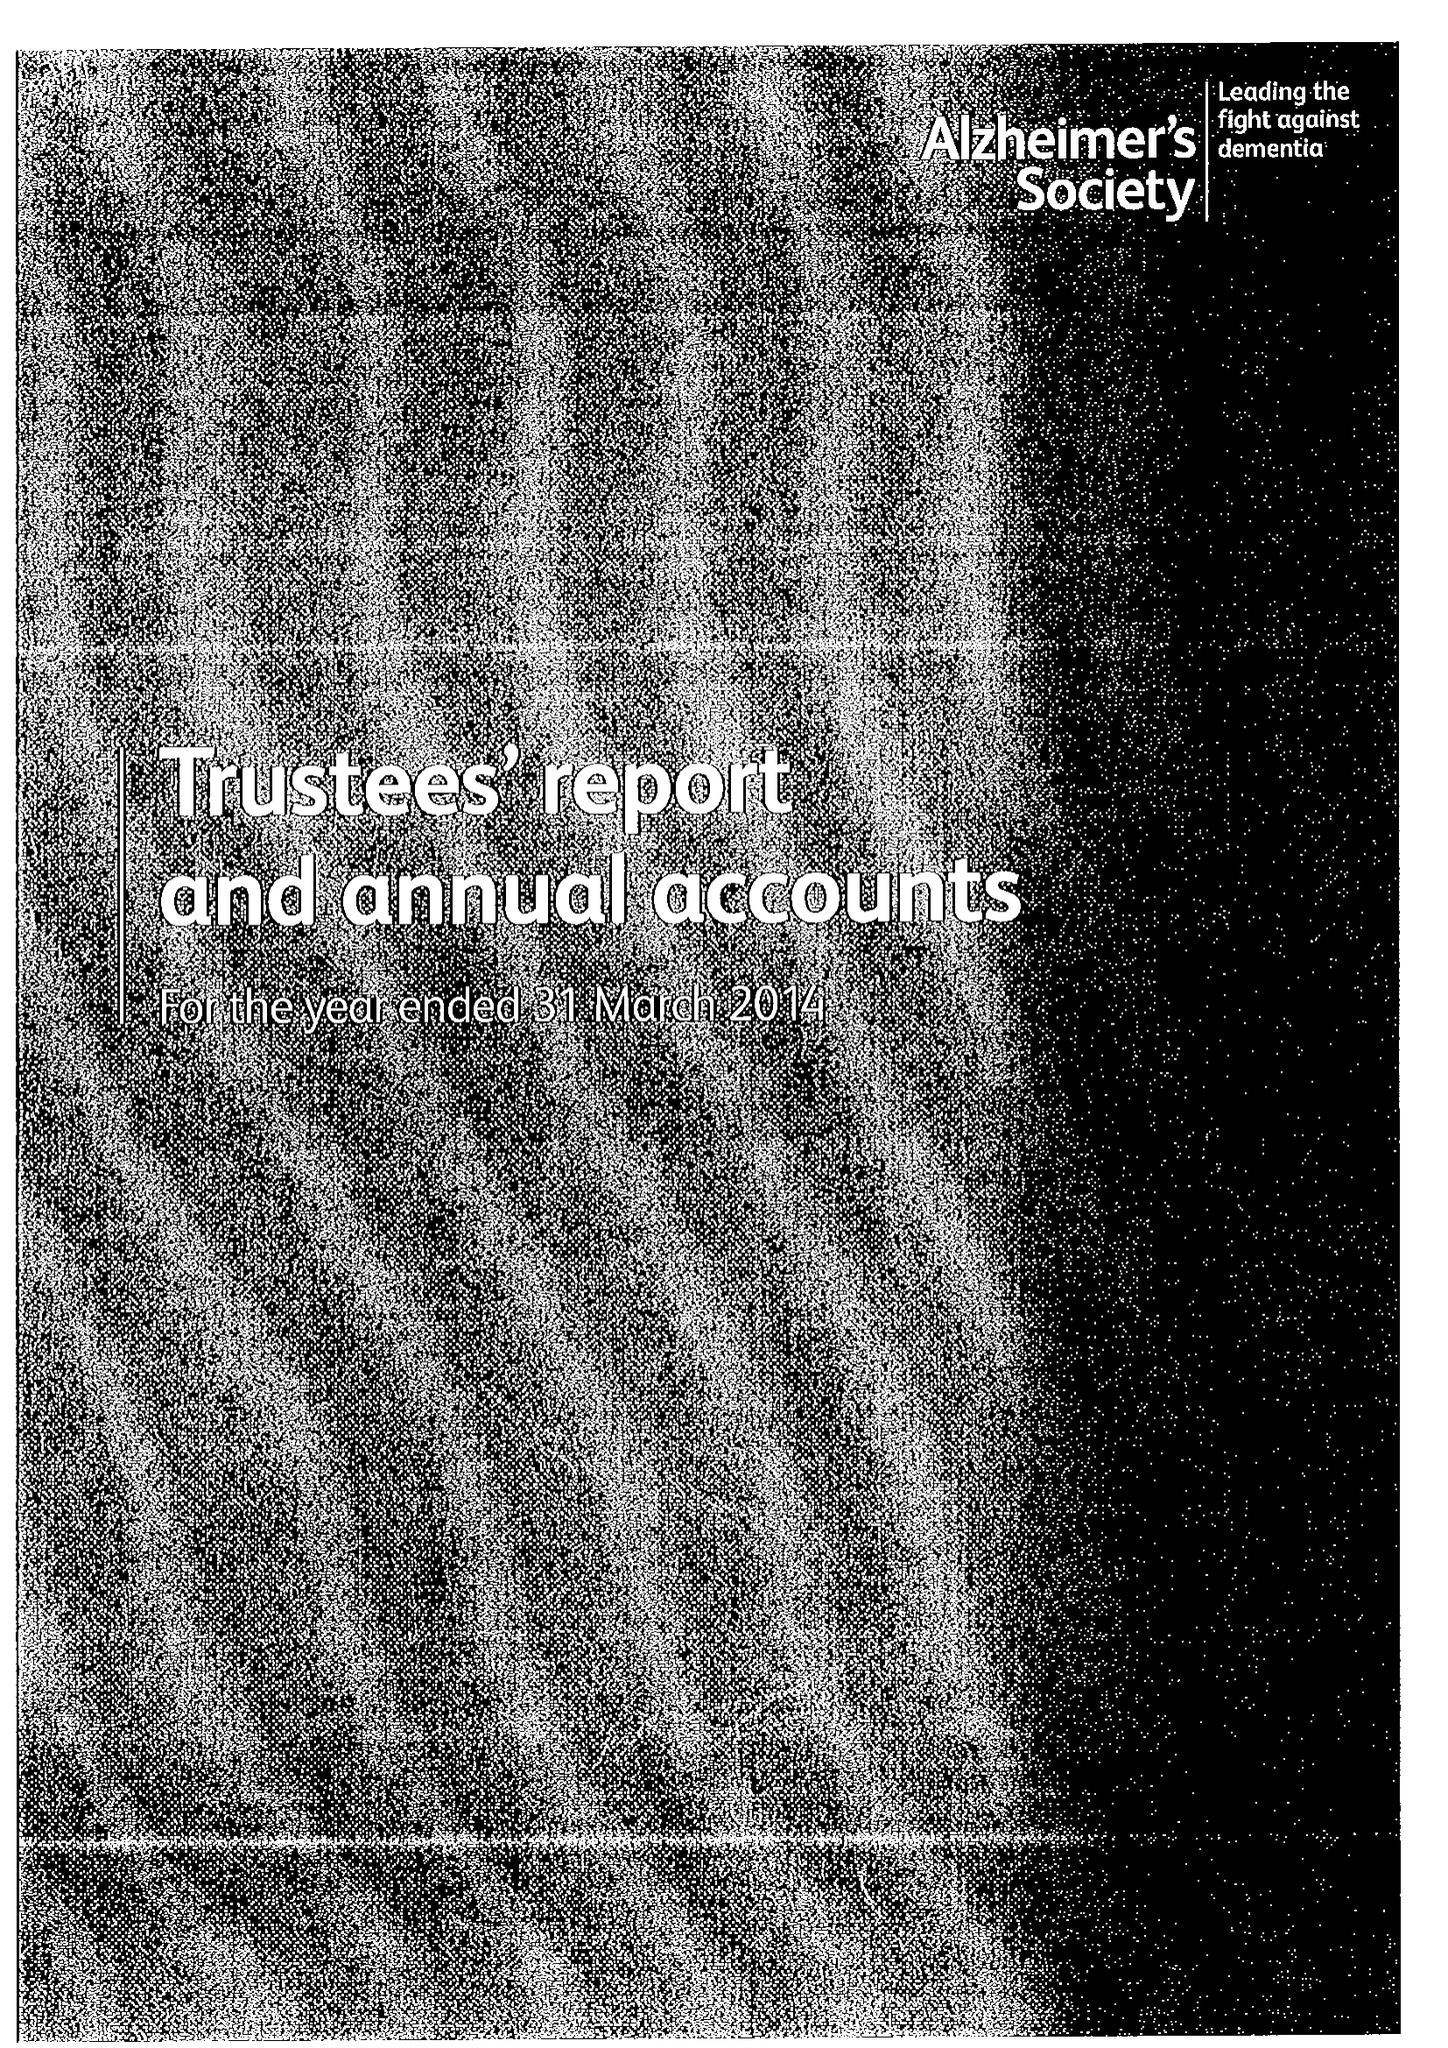What is the value for the spending_annually_in_british_pounds?
Answer the question using a single word or phrase. 74699000.00 